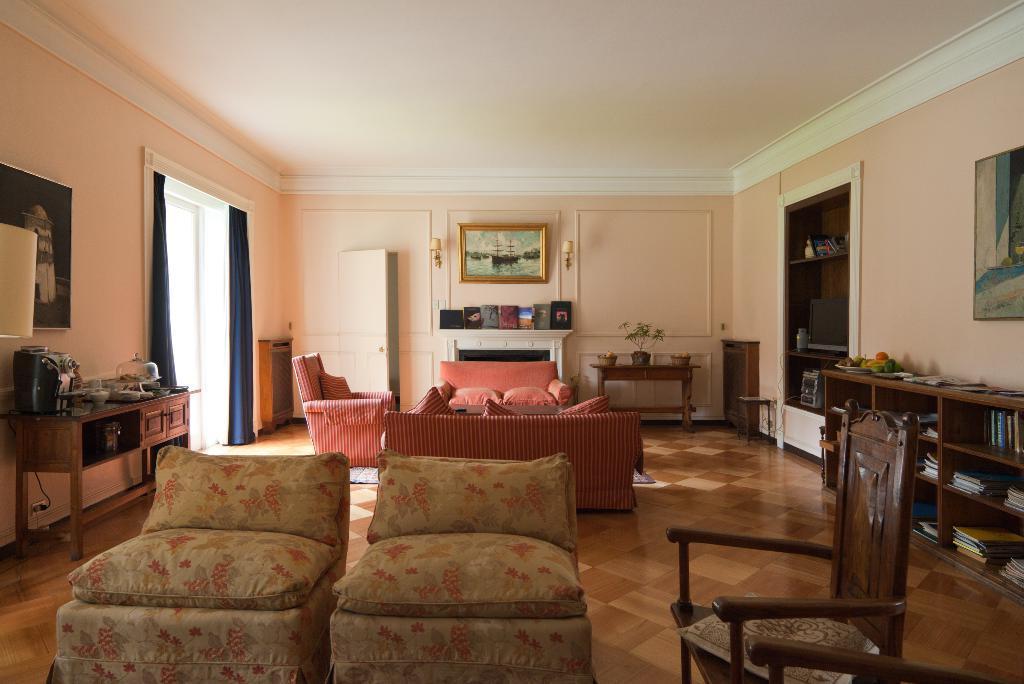How would you summarize this image in a sentence or two? there is a living room in that there are sofa chairs cupboards photo frames 